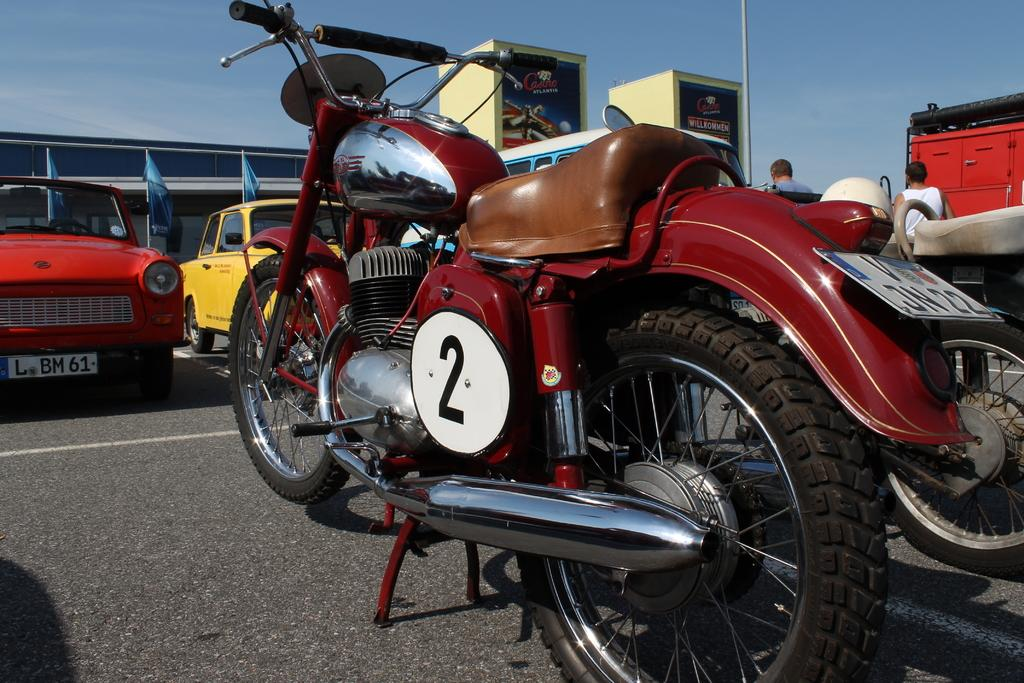<image>
Write a terse but informative summary of the picture. A red vintage motorcycle with a brown leather seat and a number two on its side. 